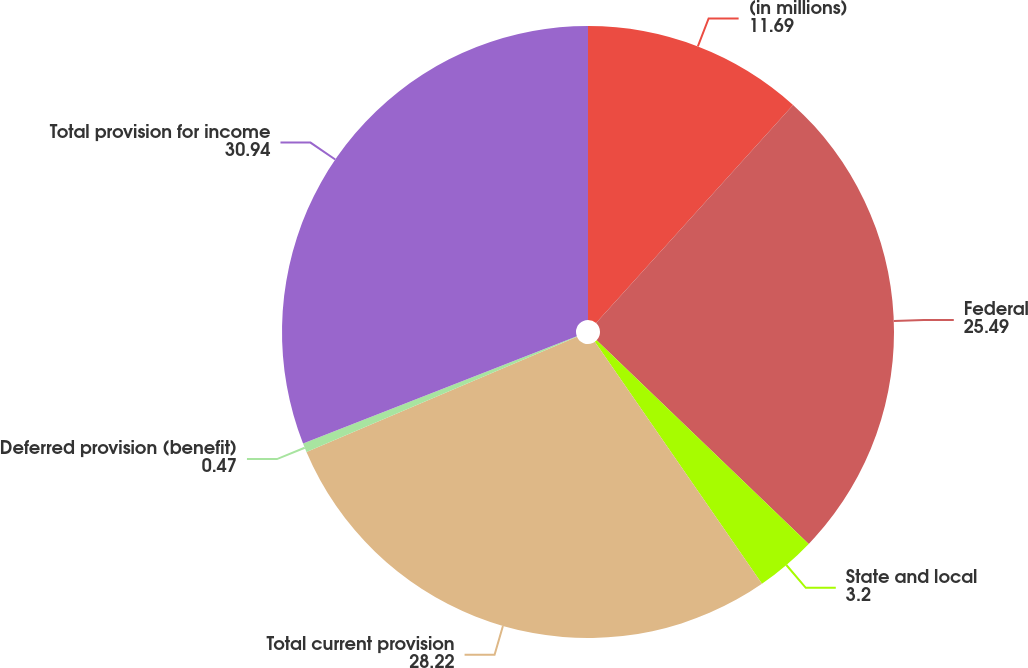Convert chart. <chart><loc_0><loc_0><loc_500><loc_500><pie_chart><fcel>(in millions)<fcel>Federal<fcel>State and local<fcel>Total current provision<fcel>Deferred provision (benefit)<fcel>Total provision for income<nl><fcel>11.69%<fcel>25.49%<fcel>3.2%<fcel>28.22%<fcel>0.47%<fcel>30.94%<nl></chart> 